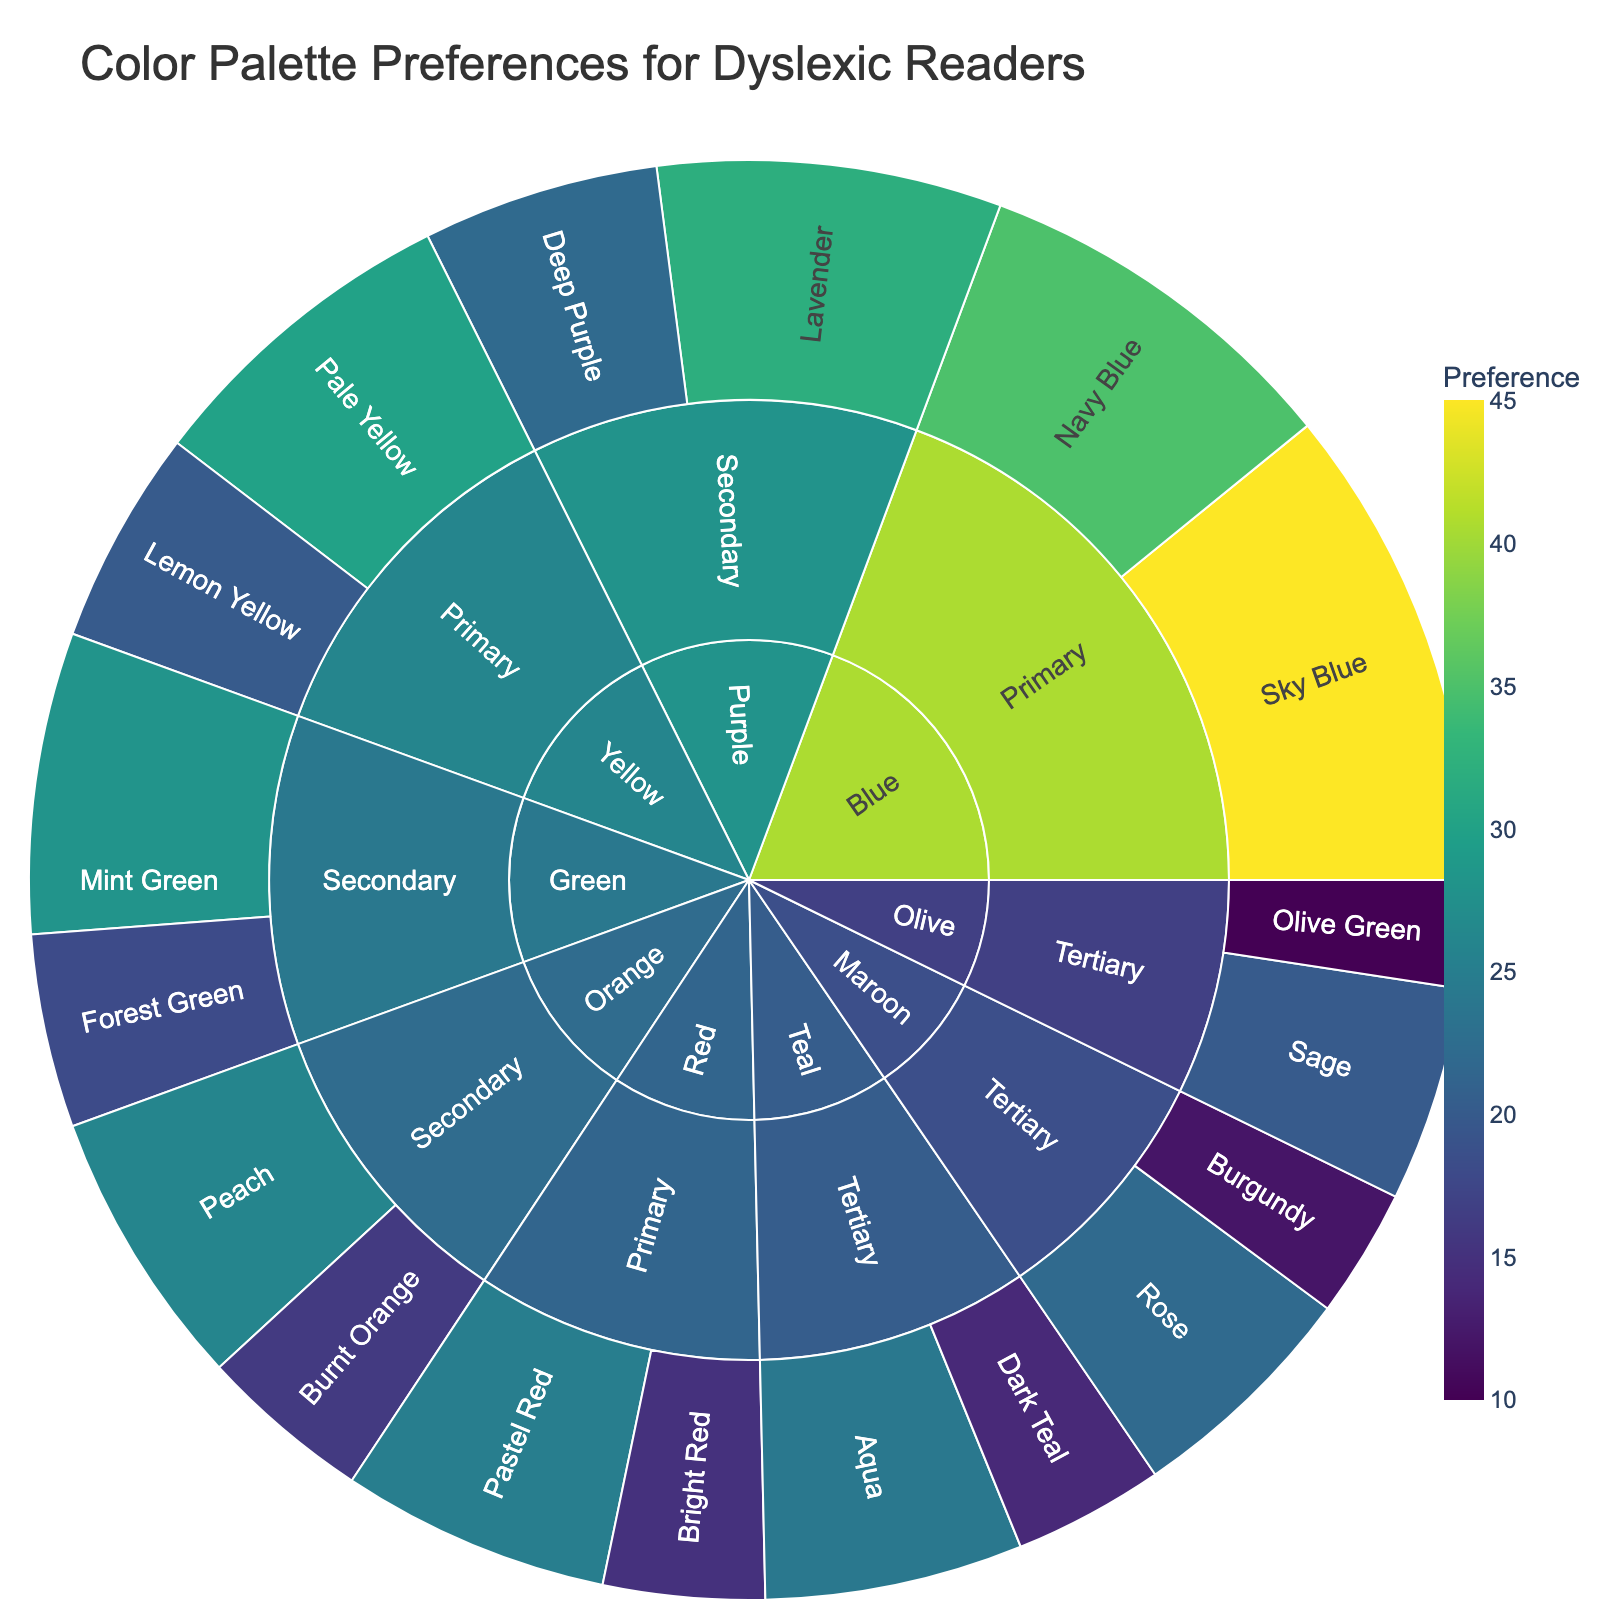Which primary color has the highest preference? Look at the preference values for the primary colors (Red, Blue, and Yellow) and identify the highest value. Blue (Navy Blue and Sky Blue) has the total preference of 80, which is the highest among primary colors.
Answer: Blue What is the total preference for secondary colors? Sum the preference values of all secondary color shades: Forest Green (18), Mint Green (28), Deep Purple (22), Lavender (32), Burnt Orange (16), and Peach (26). Total preference is 18 + 28 + 22 + 32 + 16 + 26 = 142
Answer: 142 Which shades of tertiary colors have the lowest preference? Look at the preference values for all shades of tertiary colors and identify the minimum values. Dark Teal has 14, Burgundy has 12, and Olive Green has 10.
Answer: Olive Green Which is more preferred, Primary Red or any Tertiary color? Compare the sum of preferences for Primary Red shades (Bright Red: 15 + Pastel Red: 25) with any Tertiary color shades, such as Maroon (Burgundy: 12 + Rose: 22). The Primary Red total is 40, while the Tertiary Maroon total is 34, so Primary Red is more preferred.
Answer: Primary Red What is the average preference for shades in the Primary Blue category? Calculate the preferences for Navy Blue (35) and Sky Blue (45). The average is (35 + 45) / 2 = 40
Answer: 40 Which shade of Secondary Green has a higher preference? Compare the preference value of Forest Green (18) and Mint Green (28).
Answer: Mint Green How many more points of preference does Lavender have than Sage? Identify the preferences of Lavender (32) and Sage (20) and calculate the difference. 32 - 20 = 12
Answer: 12 Which category, Primary or Secondary, has a higher cumulative preference? Sum the overall preferences of Primary (15 + 25 + 35 + 45 + 20 + 30 = 170) and Secondary (18 + 28 + 22 + 32 + 16 + 26 = 142). The Primary category has a higher preference with 170.
Answer: Primary Compare the preferences between shade pairs from different colors with equal levels, e.g., Primary Red (Pastel Red) and Secondary Orange (Peach). Compare the preference of Pastel Red (25) from Primary Red and Peach (26) from Secondary Orange.
Answer: Peach 